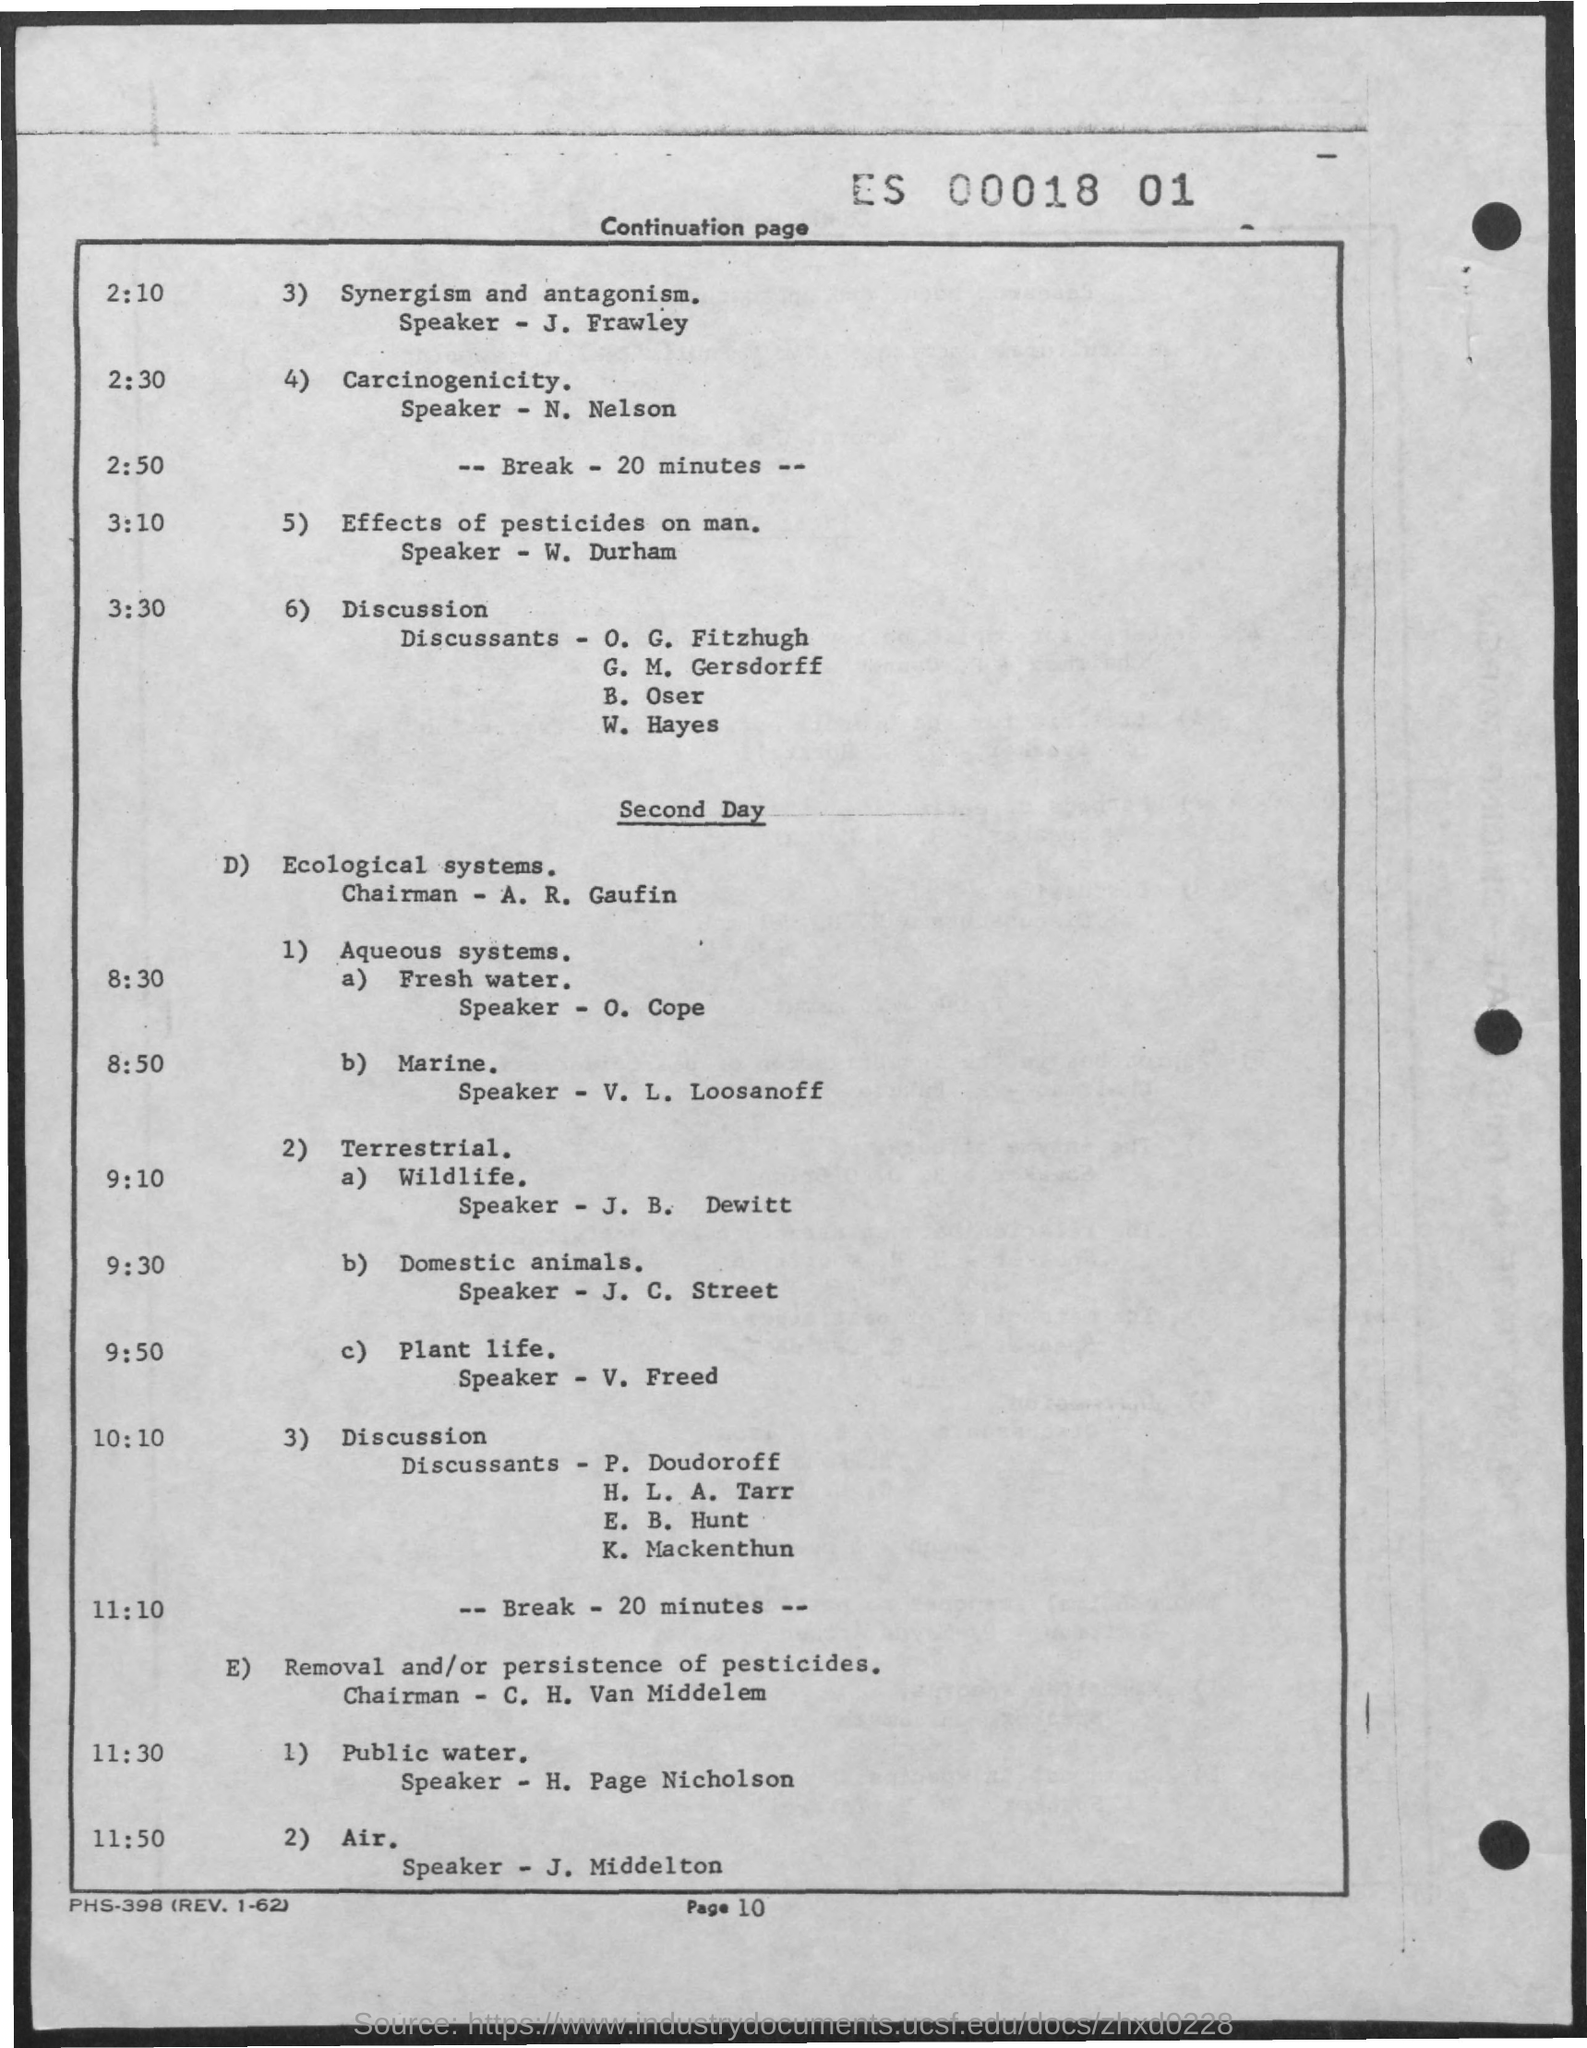Who is the speaker on synergism and antagonism?
Keep it short and to the point. J. Frawley. Who is the speaker on effects of pesticides on man?
Provide a short and direct response. W. Durham. Who is the speaker on fresh water on second day?
Offer a very short reply. O. Cope. Who is the speaker on marine?
Give a very brief answer. V. L. Loosanoff. Who is the speaker on wildlife ?
Offer a terse response. J. B. Dewitt. Who is the speaker on Domestic Animals?
Your answer should be very brief. J. C. Street. Who is the speaker on plant life?
Keep it short and to the point. V. Freed. Who is the speaker on public water?
Give a very brief answer. H. Page Nicholson. 